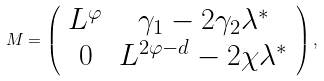<formula> <loc_0><loc_0><loc_500><loc_500>M = \left ( \begin{array} { c c } L ^ { \varphi } & \gamma _ { 1 } - 2 \gamma _ { 2 } \lambda ^ { * } \\ 0 & L ^ { 2 \varphi - d } - 2 \chi \lambda ^ { * } \end{array} \right ) ,</formula> 